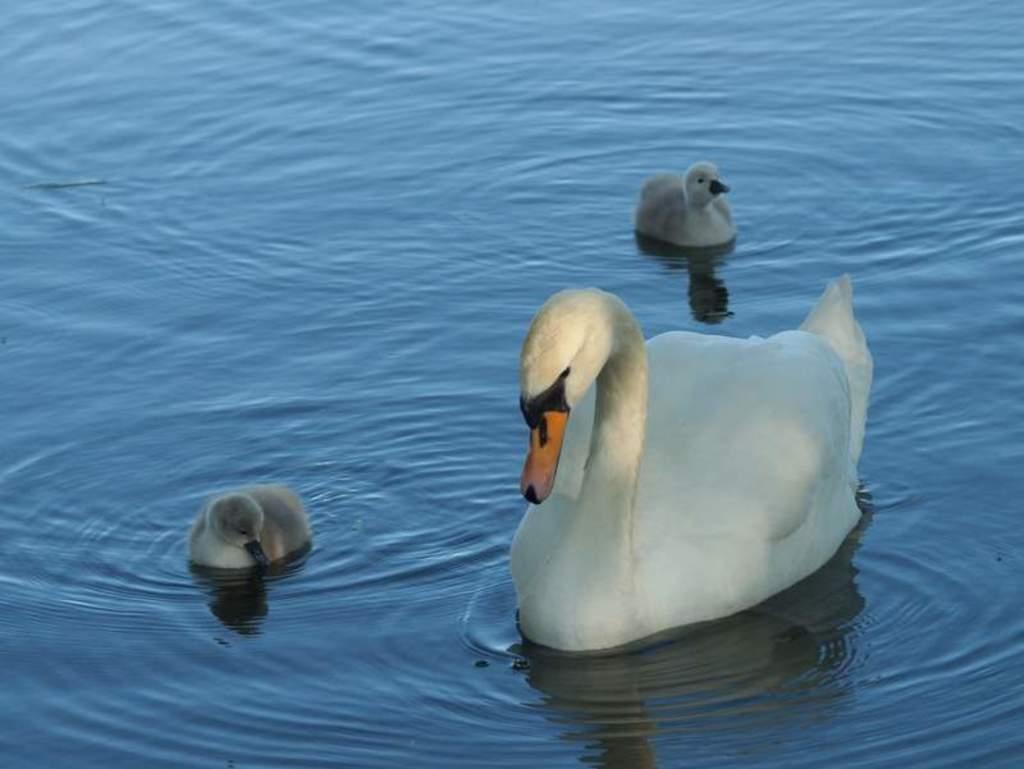Describe this image in one or two sentences. Above the water there is a swan and cygnets. 